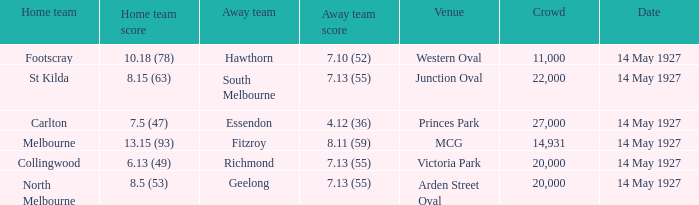Which away team had a score of 7.13 (55) against the home team North Melbourne? Geelong. 